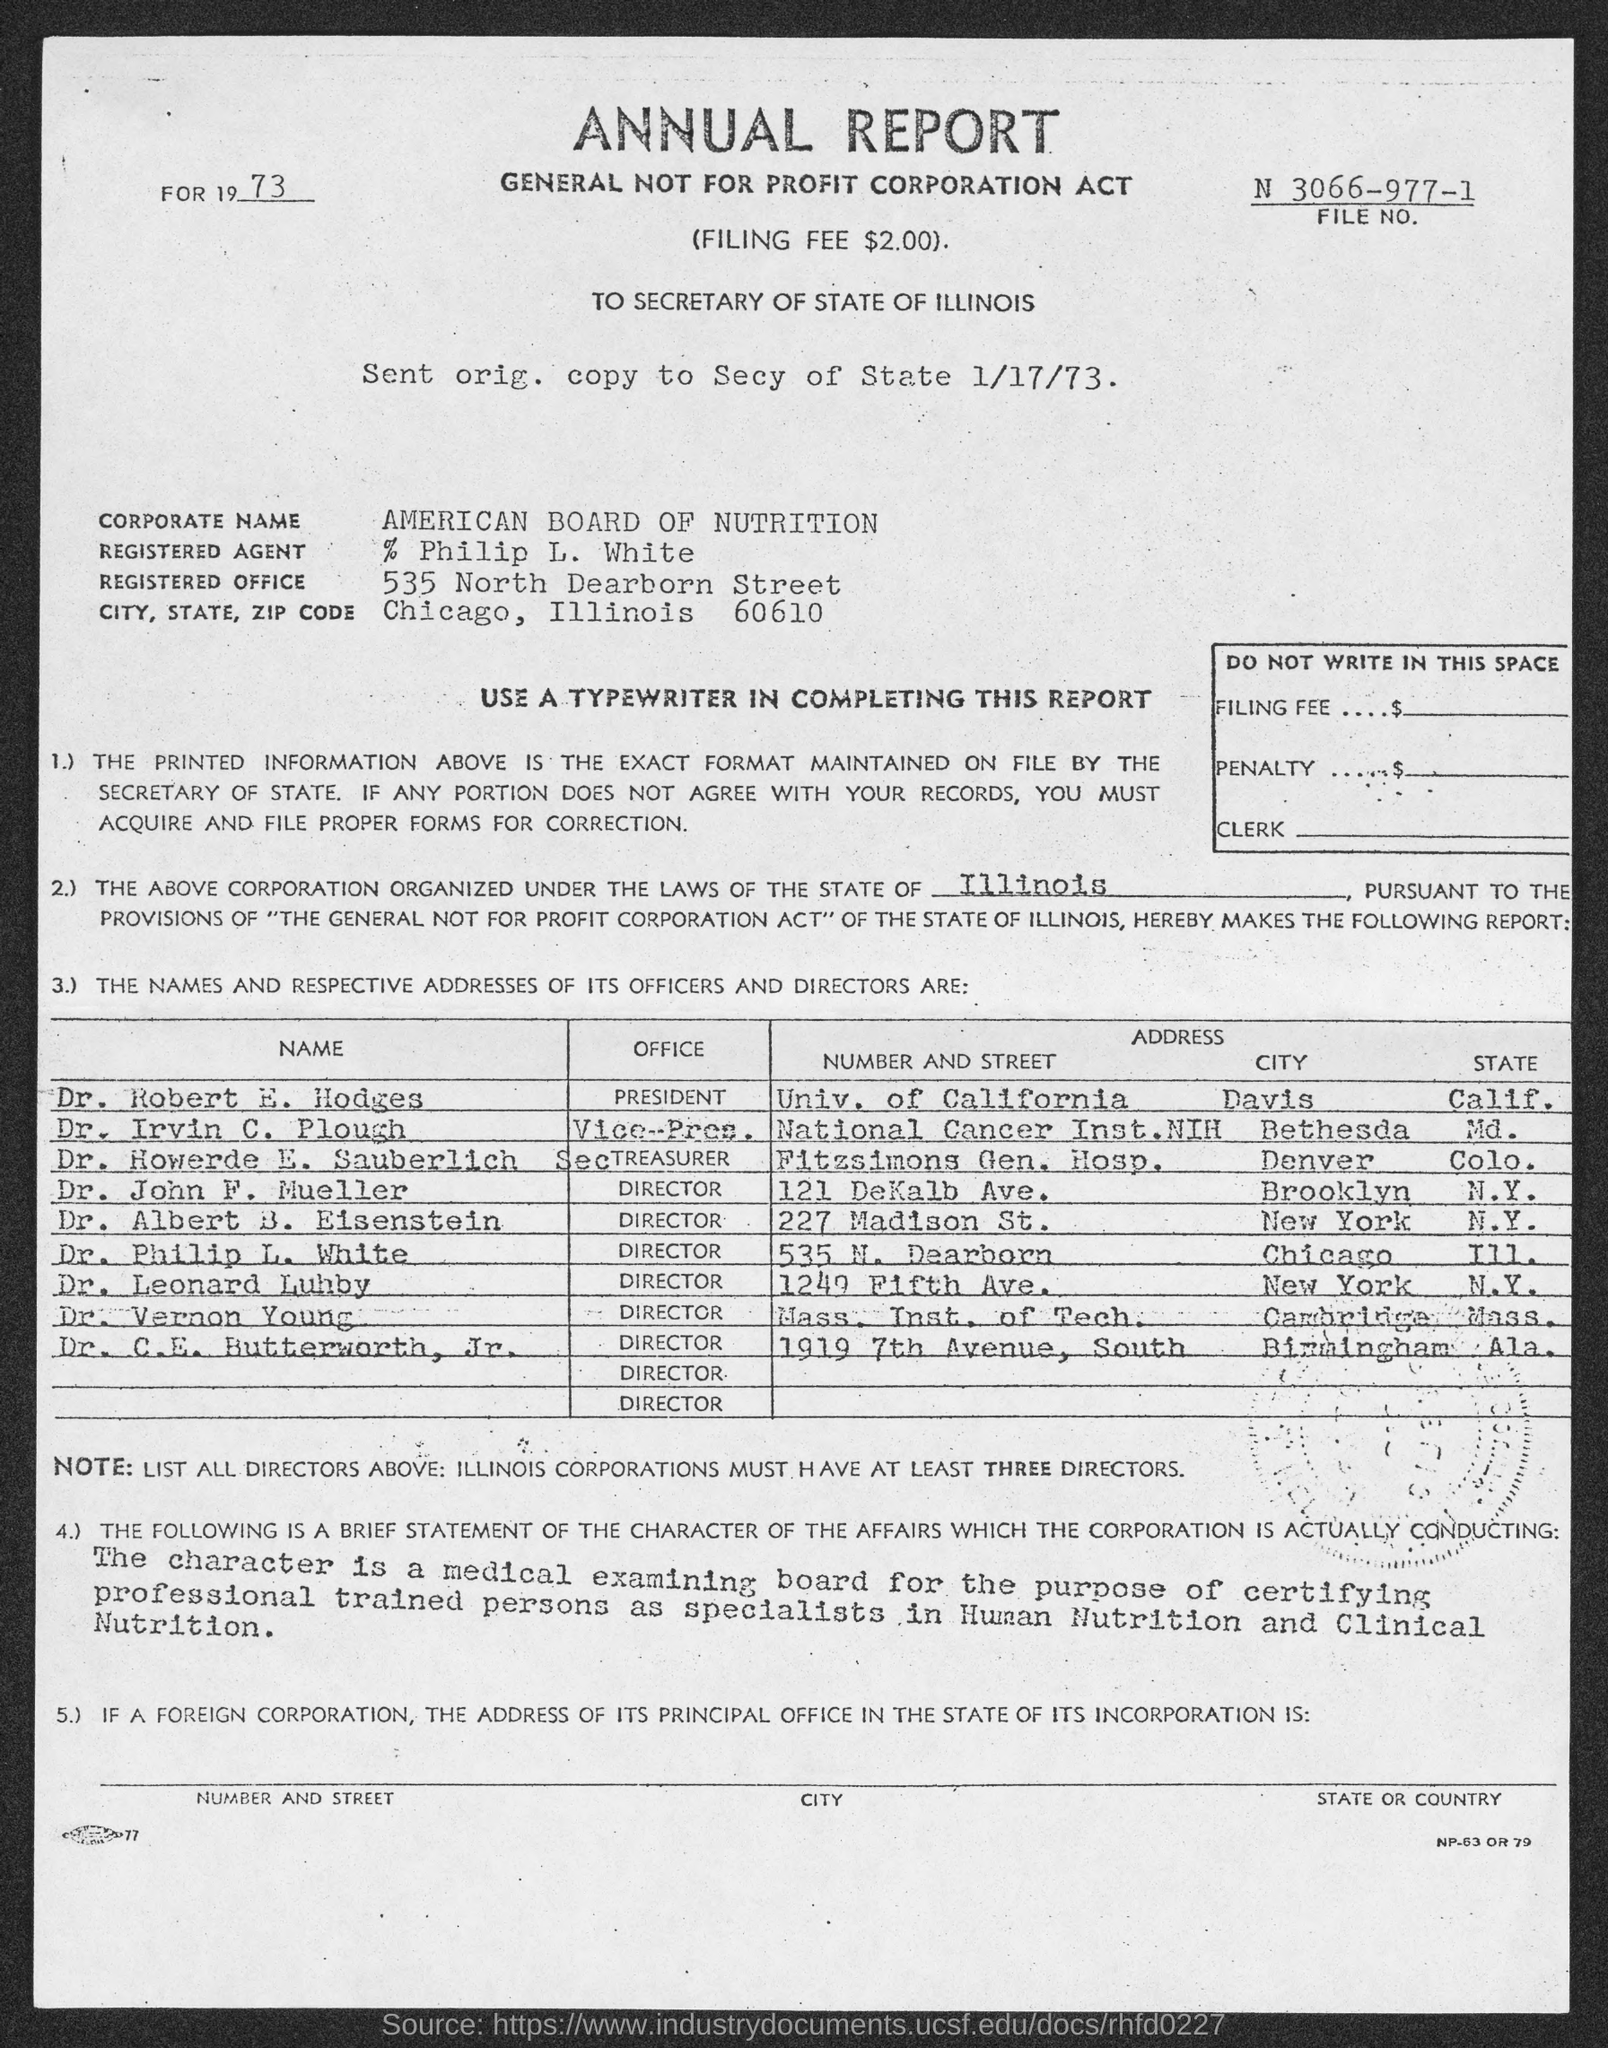What is the File No. mentioned in the document?
Offer a very short reply. N 3066-977-1. Who is the registered agent given in the document?
Your response must be concise. % Philip L. White. What is the City, State, Zipcode given in the document?
Offer a very short reply. Chicago, illinois 60610. What is the Corporate Name mentioned in the document?
Your answer should be very brief. American board of nutrition. Who is the Vice- Pres. , National Cancer Inst. NIH?
Your response must be concise. Dr. Irvin C. Plough. 